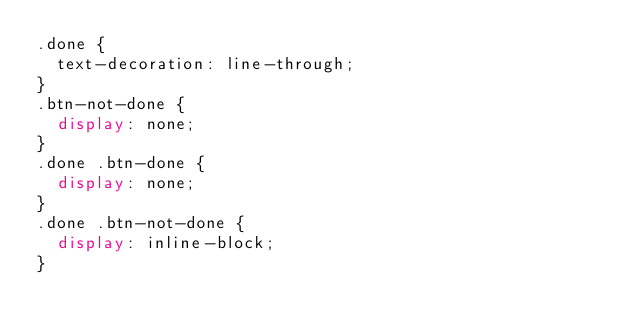<code> <loc_0><loc_0><loc_500><loc_500><_CSS_>.done {
  text-decoration: line-through;
}
.btn-not-done {
  display: none;
}
.done .btn-done {
  display: none;
}
.done .btn-not-done {
  display: inline-block;
}
</code> 